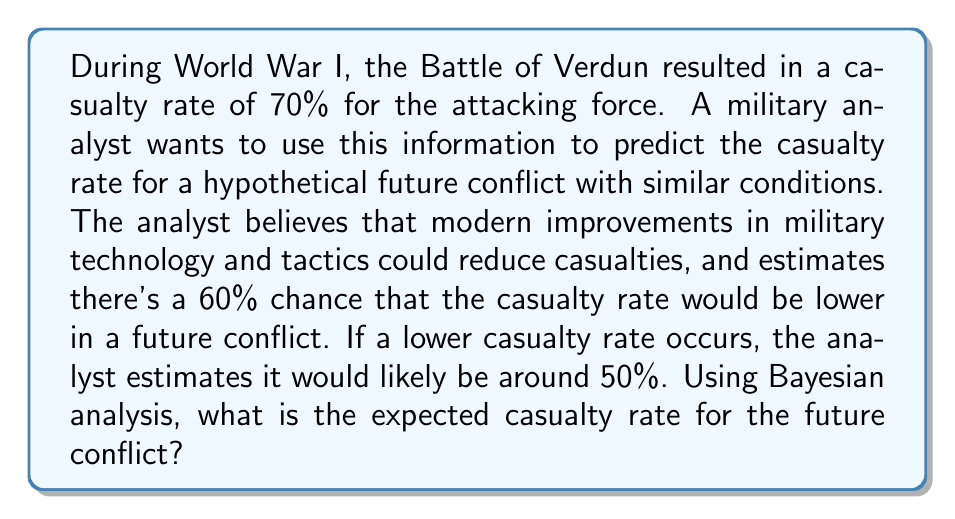Solve this math problem. Let's approach this problem using Bayesian analysis:

1. Define our variables:
   $A$: Event that casualty rate is lower in future conflict
   $\bar{A}$: Event that casualty rate is not lower (i.e., remains the same)
   $R$: Casualty rate

2. Given information:
   $P(A) = 0.60$ (Prior probability of lower casualty rate)
   $P(\bar{A}) = 1 - P(A) = 0.40$
   $R(A) = 0.50$ (Estimated casualty rate if lower)
   $R(\bar{A}) = 0.70$ (Original WWI casualty rate)

3. Calculate the expected casualty rate using the law of total expectation:

   $$E[R] = E[R|A] \cdot P(A) + E[R|\bar{A}] \cdot P(\bar{A})$$

4. Substitute the values:

   $$E[R] = 0.50 \cdot 0.60 + 0.70 \cdot 0.40$$

5. Calculate:

   $$E[R] = 0.30 + 0.28 = 0.58$$

Therefore, the expected casualty rate for the future conflict is 58%.
Answer: The expected casualty rate for the future conflict is 58%. 